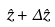Convert formula to latex. <formula><loc_0><loc_0><loc_500><loc_500>\hat { z } + \Delta \hat { z }</formula> 